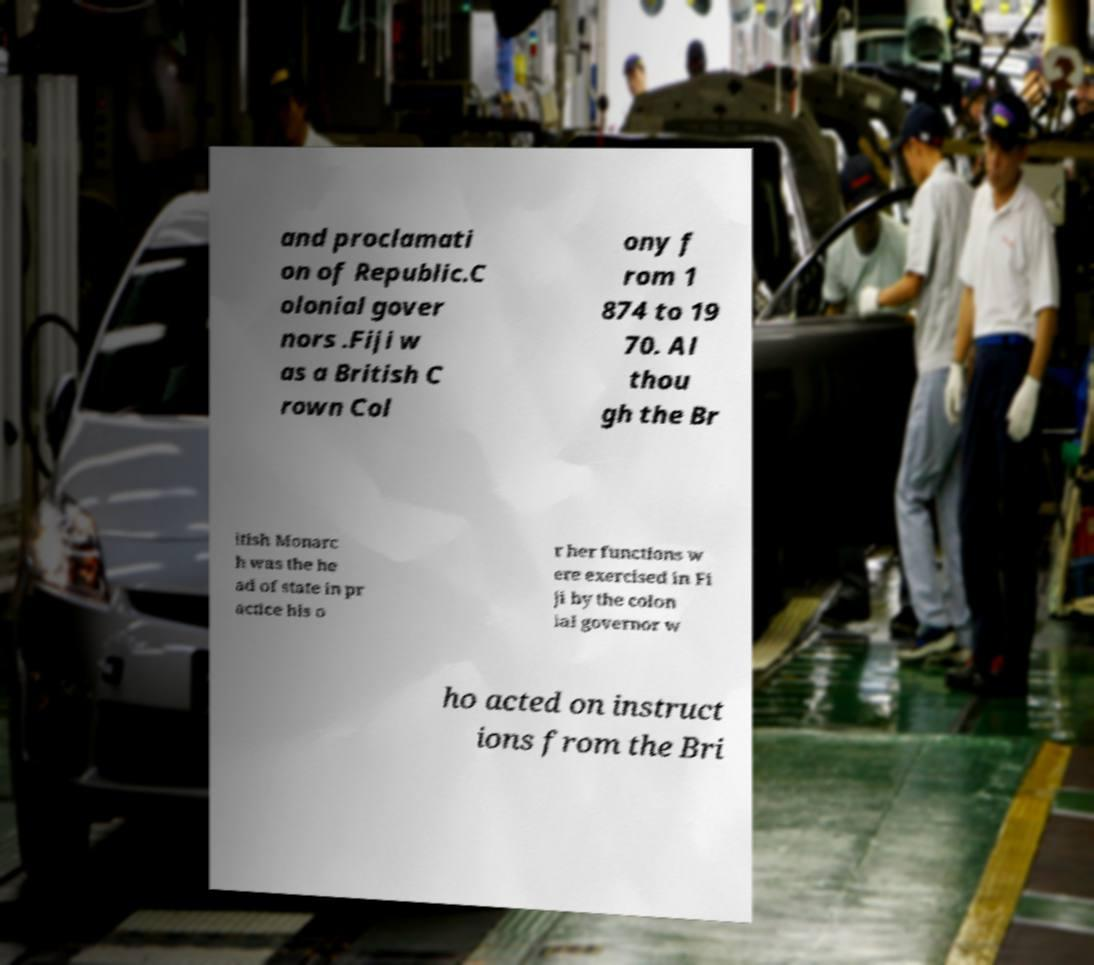Can you accurately transcribe the text from the provided image for me? and proclamati on of Republic.C olonial gover nors .Fiji w as a British C rown Col ony f rom 1 874 to 19 70. Al thou gh the Br itish Monarc h was the he ad of state in pr actice his o r her functions w ere exercised in Fi ji by the colon ial governor w ho acted on instruct ions from the Bri 